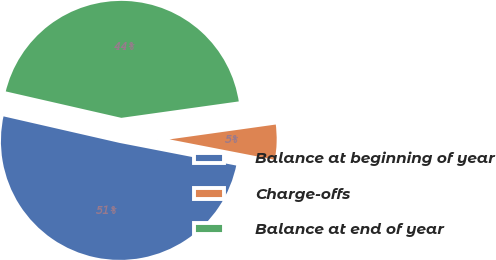Convert chart. <chart><loc_0><loc_0><loc_500><loc_500><pie_chart><fcel>Balance at beginning of year<fcel>Charge-offs<fcel>Balance at end of year<nl><fcel>50.53%<fcel>5.26%<fcel>44.21%<nl></chart> 